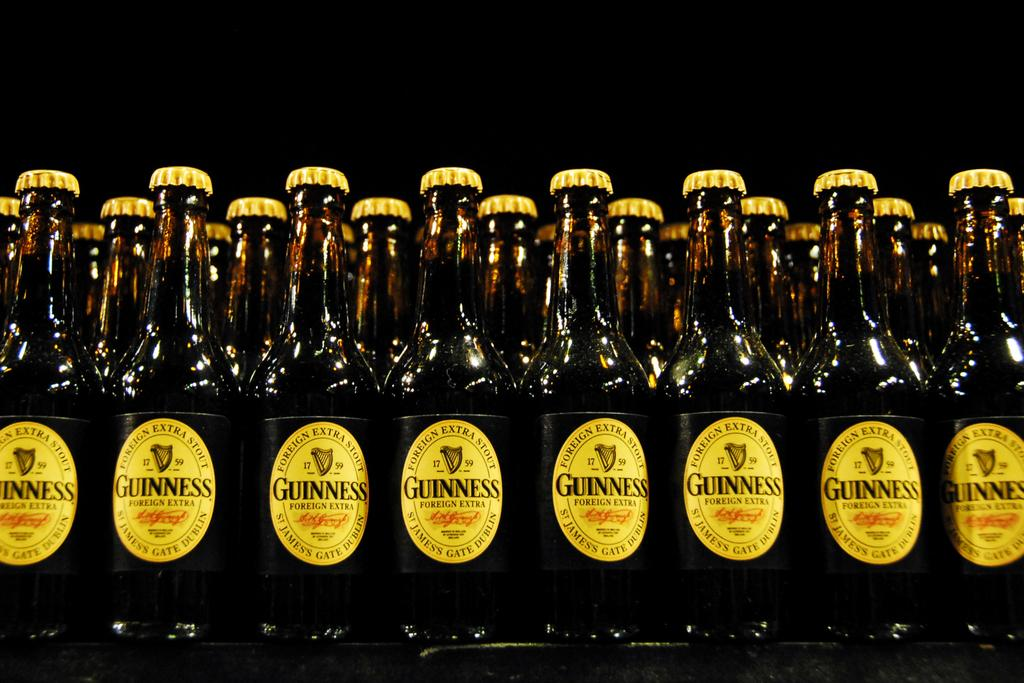<image>
Relay a brief, clear account of the picture shown. A large collection of Guinness dark stout beer on a table. 